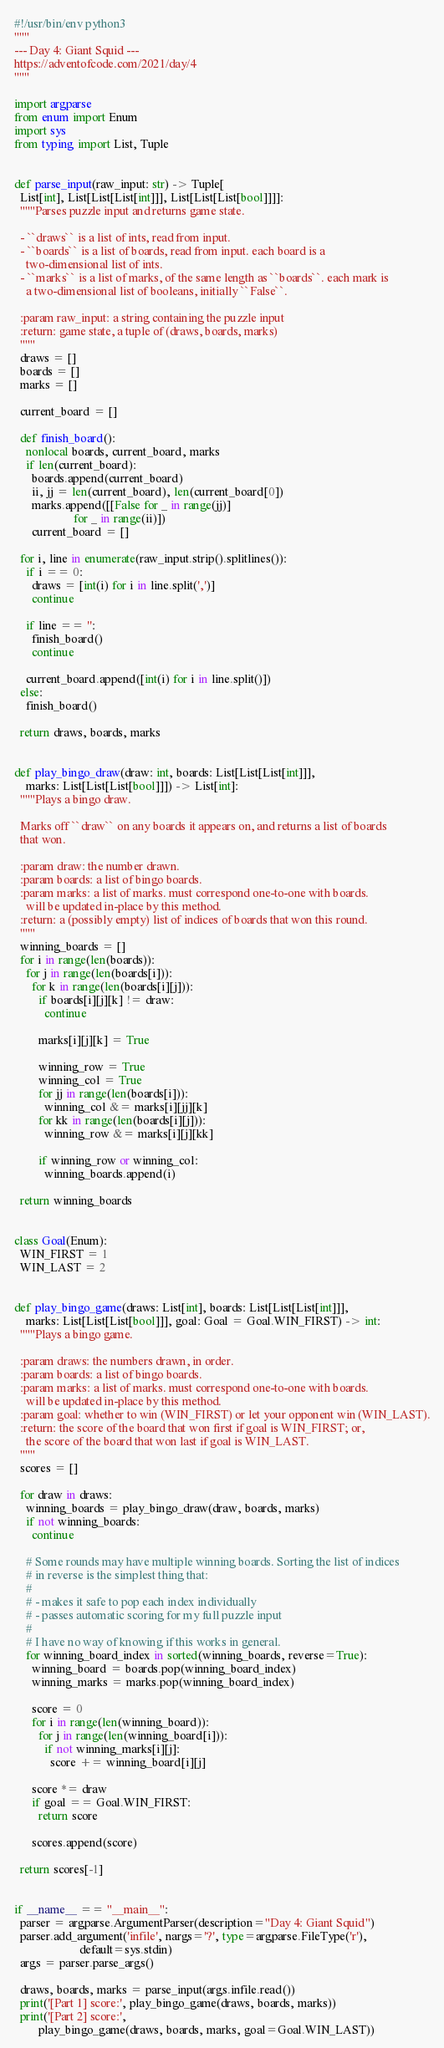<code> <loc_0><loc_0><loc_500><loc_500><_Python_>#!/usr/bin/env python3
"""
--- Day 4: Giant Squid ---
https://adventofcode.com/2021/day/4
"""

import argparse
from enum import Enum
import sys
from typing import List, Tuple


def parse_input(raw_input: str) -> Tuple[
  List[int], List[List[List[int]]], List[List[List[bool]]]]:
  """Parses puzzle input and returns game state.

  - ``draws`` is a list of ints, read from input.
  - ``boards`` is a list of boards, read from input. each board is a
    two-dimensional list of ints.
  - ``marks`` is a list of marks, of the same length as ``boards``. each mark is
    a two-dimensional list of booleans, initially ``False``.

  :param raw_input: a string containing the puzzle input
  :return: game state, a tuple of (draws, boards, marks)
  """
  draws = []
  boards = []
  marks = []

  current_board = []

  def finish_board():
    nonlocal boards, current_board, marks
    if len(current_board):
      boards.append(current_board)
      ii, jj = len(current_board), len(current_board[0])
      marks.append([[False for _ in range(jj)]
                    for _ in range(ii)])
      current_board = []

  for i, line in enumerate(raw_input.strip().splitlines()):
    if i == 0:
      draws = [int(i) for i in line.split(',')]
      continue

    if line == '':
      finish_board()
      continue

    current_board.append([int(i) for i in line.split()])
  else:
    finish_board()

  return draws, boards, marks


def play_bingo_draw(draw: int, boards: List[List[List[int]]],
    marks: List[List[List[bool]]]) -> List[int]:
  """Plays a bingo draw.

  Marks off ``draw`` on any boards it appears on, and returns a list of boards
  that won.

  :param draw: the number drawn.
  :param boards: a list of bingo boards.
  :param marks: a list of marks. must correspond one-to-one with boards.
    will be updated in-place by this method.
  :return: a (possibly empty) list of indices of boards that won this round.
  """
  winning_boards = []
  for i in range(len(boards)):
    for j in range(len(boards[i])):
      for k in range(len(boards[i][j])):
        if boards[i][j][k] != draw:
          continue

        marks[i][j][k] = True

        winning_row = True
        winning_col = True
        for jj in range(len(boards[i])):
          winning_col &= marks[i][jj][k]
        for kk in range(len(boards[i][j])):
          winning_row &= marks[i][j][kk]

        if winning_row or winning_col:
          winning_boards.append(i)

  return winning_boards


class Goal(Enum):
  WIN_FIRST = 1
  WIN_LAST = 2


def play_bingo_game(draws: List[int], boards: List[List[List[int]]],
    marks: List[List[List[bool]]], goal: Goal = Goal.WIN_FIRST) -> int:
  """Plays a bingo game.

  :param draws: the numbers drawn, in order.
  :param boards: a list of bingo boards.
  :param marks: a list of marks. must correspond one-to-one with boards.
    will be updated in-place by this method.
  :param goal: whether to win (WIN_FIRST) or let your opponent win (WIN_LAST).
  :return: the score of the board that won first if goal is WIN_FIRST; or,
    the score of the board that won last if goal is WIN_LAST.
  """
  scores = []

  for draw in draws:
    winning_boards = play_bingo_draw(draw, boards, marks)
    if not winning_boards:
      continue

    # Some rounds may have multiple winning boards. Sorting the list of indices
    # in reverse is the simplest thing that:
    #
    # - makes it safe to pop each index individually
    # - passes automatic scoring for my full puzzle input
    #
    # I have no way of knowing if this works in general.
    for winning_board_index in sorted(winning_boards, reverse=True):
      winning_board = boards.pop(winning_board_index)
      winning_marks = marks.pop(winning_board_index)

      score = 0
      for i in range(len(winning_board)):
        for j in range(len(winning_board[i])):
          if not winning_marks[i][j]:
            score += winning_board[i][j]

      score *= draw
      if goal == Goal.WIN_FIRST:
        return score

      scores.append(score)

  return scores[-1]


if __name__ == "__main__":
  parser = argparse.ArgumentParser(description="Day 4: Giant Squid")
  parser.add_argument('infile', nargs='?', type=argparse.FileType('r'),
                      default=sys.stdin)
  args = parser.parse_args()

  draws, boards, marks = parse_input(args.infile.read())
  print('[Part 1] score:', play_bingo_game(draws, boards, marks))
  print('[Part 2] score:',
        play_bingo_game(draws, boards, marks, goal=Goal.WIN_LAST))
</code> 